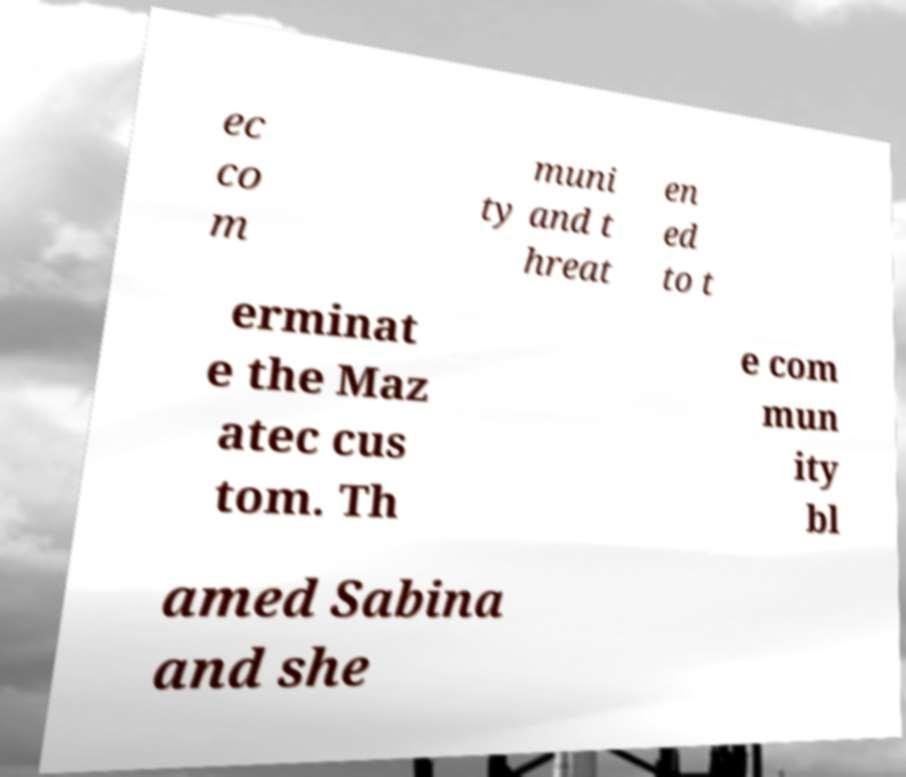Please identify and transcribe the text found in this image. ec co m muni ty and t hreat en ed to t erminat e the Maz atec cus tom. Th e com mun ity bl amed Sabina and she 